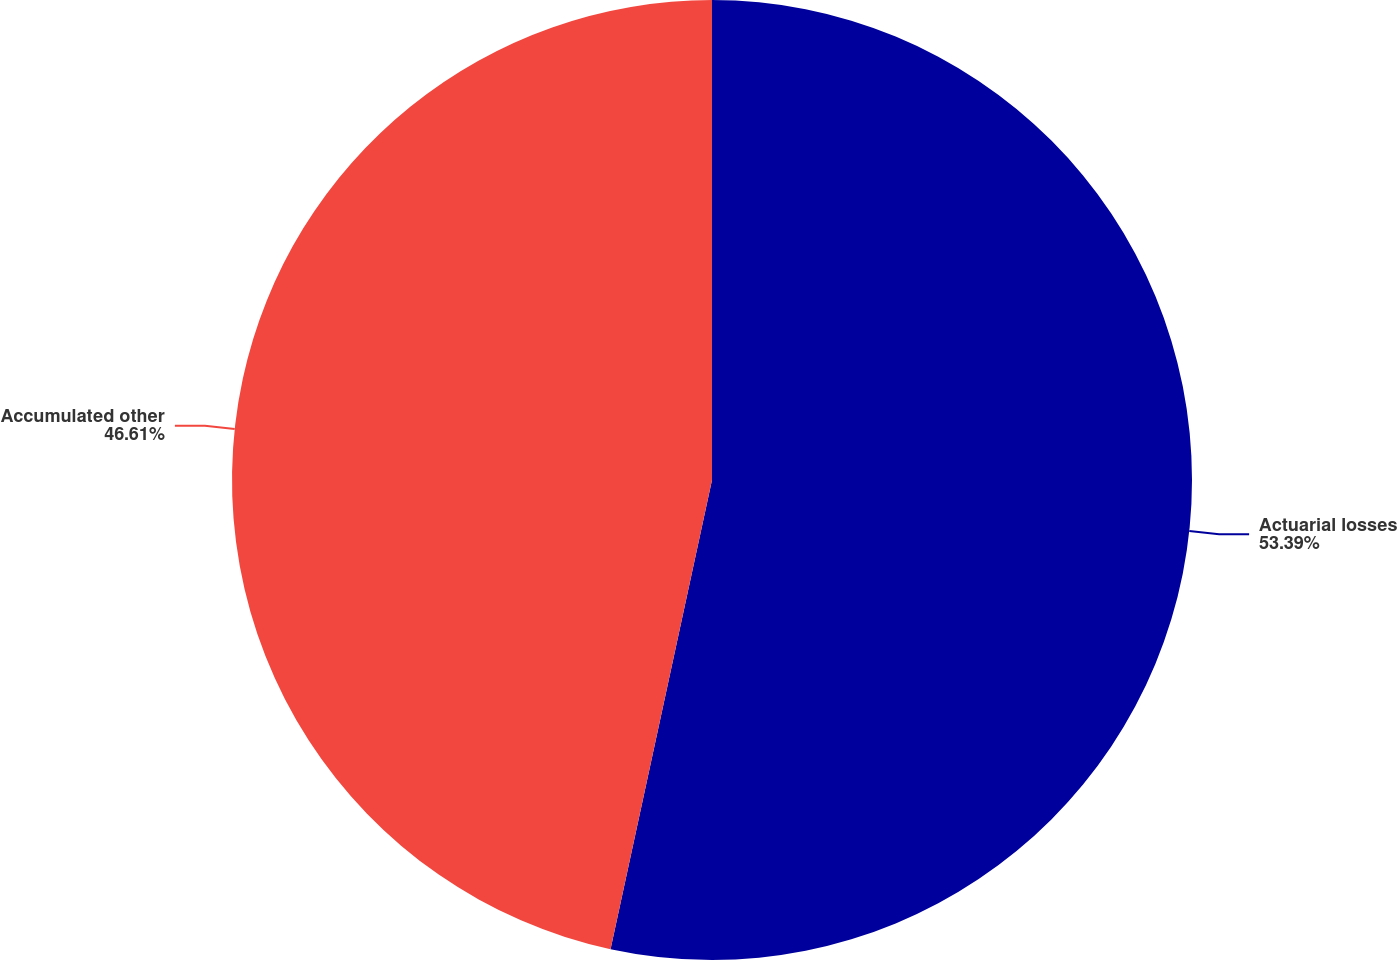Convert chart. <chart><loc_0><loc_0><loc_500><loc_500><pie_chart><fcel>Actuarial losses<fcel>Accumulated other<nl><fcel>53.39%<fcel>46.61%<nl></chart> 